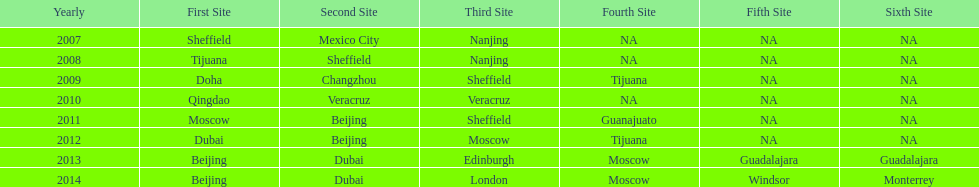Which two venue has no nations from 2007-2012 5th Venue, 6th Venue. 